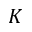Convert formula to latex. <formula><loc_0><loc_0><loc_500><loc_500>K</formula> 